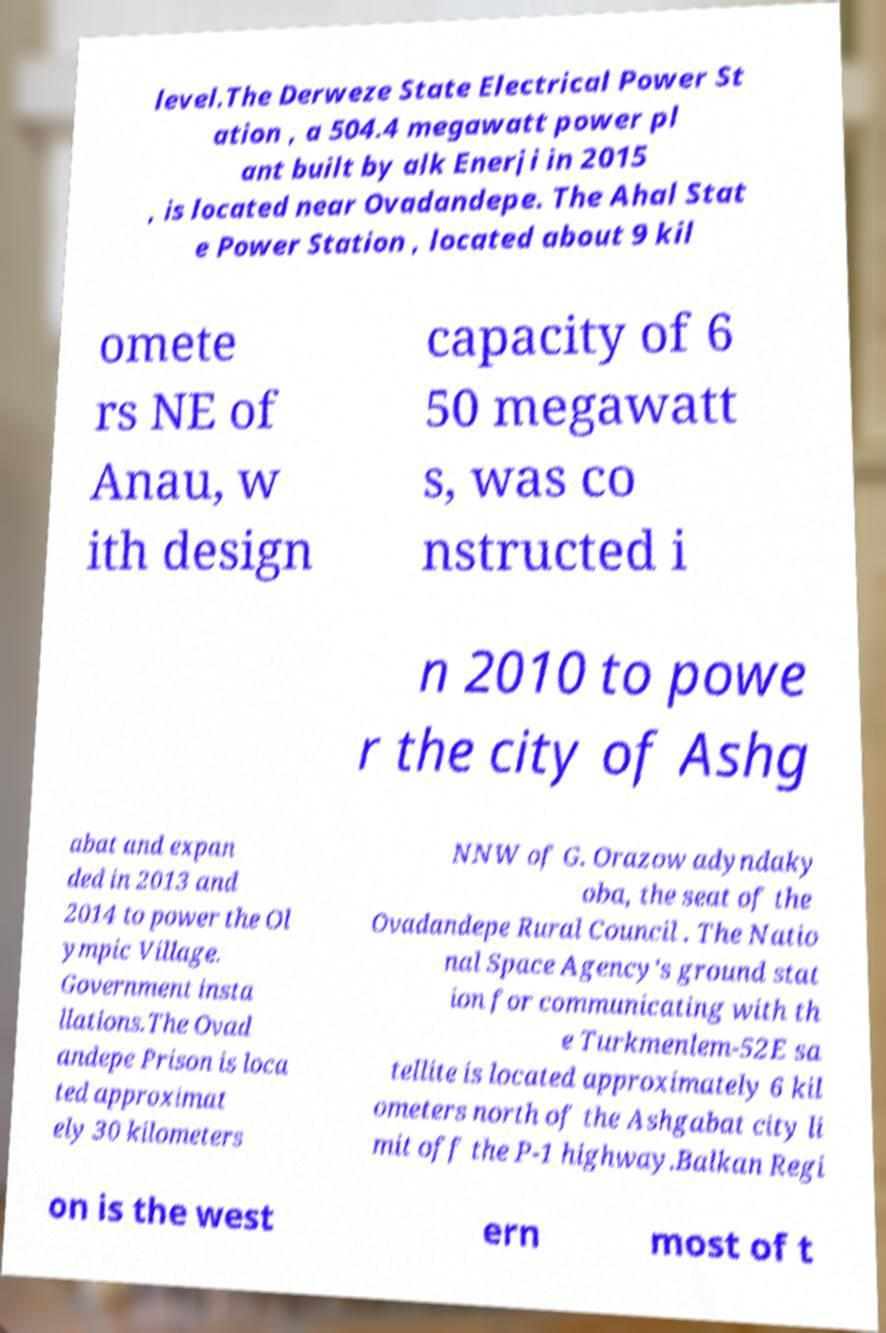Can you read and provide the text displayed in the image?This photo seems to have some interesting text. Can you extract and type it out for me? level.The Derweze State Electrical Power St ation , a 504.4 megawatt power pl ant built by alk Enerji in 2015 , is located near Ovadandepe. The Ahal Stat e Power Station , located about 9 kil omete rs NE of Anau, w ith design capacity of 6 50 megawatt s, was co nstructed i n 2010 to powe r the city of Ashg abat and expan ded in 2013 and 2014 to power the Ol ympic Village. Government insta llations.The Ovad andepe Prison is loca ted approximat ely 30 kilometers NNW of G. Orazow adyndaky oba, the seat of the Ovadandepe Rural Council . The Natio nal Space Agency's ground stat ion for communicating with th e Turkmenlem-52E sa tellite is located approximately 6 kil ometers north of the Ashgabat city li mit off the P-1 highway.Balkan Regi on is the west ern most of t 